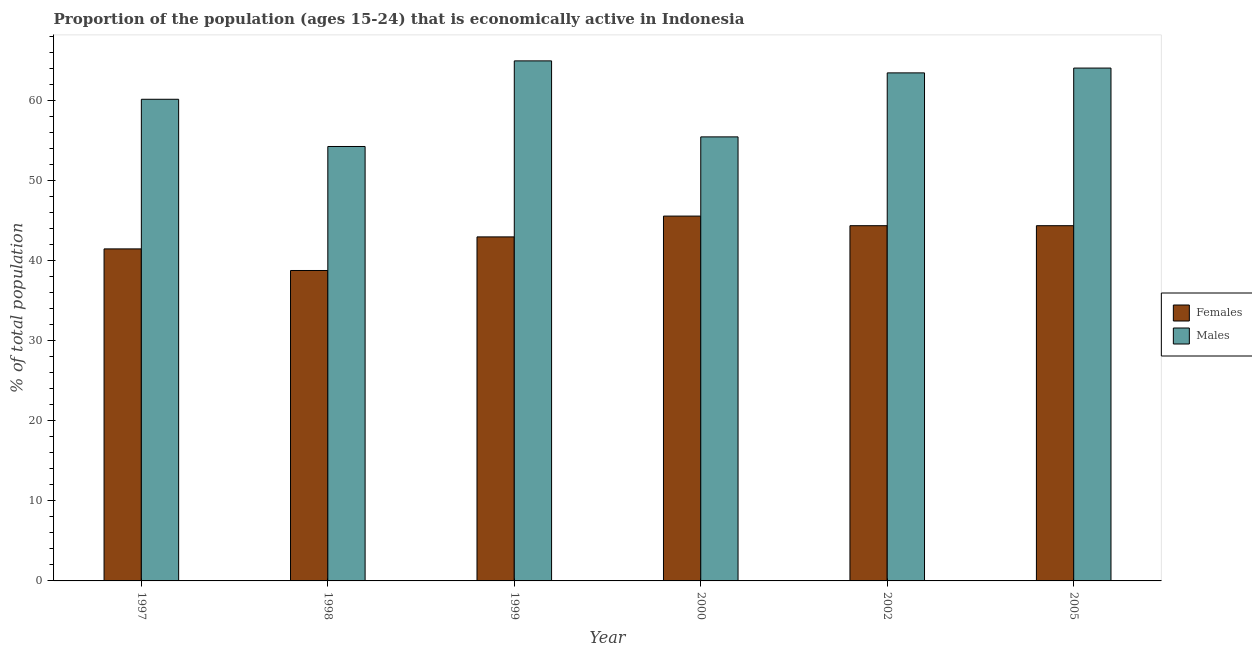How many different coloured bars are there?
Keep it short and to the point. 2. How many groups of bars are there?
Provide a short and direct response. 6. Are the number of bars per tick equal to the number of legend labels?
Offer a terse response. Yes. Are the number of bars on each tick of the X-axis equal?
Provide a succinct answer. Yes. How many bars are there on the 3rd tick from the left?
Your response must be concise. 2. What is the label of the 4th group of bars from the left?
Give a very brief answer. 2000. What is the percentage of economically active female population in 1997?
Provide a short and direct response. 41.5. Across all years, what is the maximum percentage of economically active male population?
Your answer should be compact. 65. Across all years, what is the minimum percentage of economically active male population?
Provide a short and direct response. 54.3. In which year was the percentage of economically active female population maximum?
Keep it short and to the point. 2000. What is the total percentage of economically active female population in the graph?
Provide a short and direct response. 257.7. What is the difference between the percentage of economically active male population in 1999 and that in 2005?
Give a very brief answer. 0.9. What is the difference between the percentage of economically active female population in 2005 and the percentage of economically active male population in 1999?
Provide a succinct answer. 1.4. What is the average percentage of economically active male population per year?
Provide a short and direct response. 60.43. In the year 2002, what is the difference between the percentage of economically active male population and percentage of economically active female population?
Provide a short and direct response. 0. In how many years, is the percentage of economically active male population greater than 30 %?
Provide a short and direct response. 6. What is the ratio of the percentage of economically active male population in 1997 to that in 1998?
Your response must be concise. 1.11. Is the percentage of economically active male population in 1998 less than that in 2005?
Give a very brief answer. Yes. Is the difference between the percentage of economically active female population in 2000 and 2002 greater than the difference between the percentage of economically active male population in 2000 and 2002?
Keep it short and to the point. No. What is the difference between the highest and the second highest percentage of economically active female population?
Keep it short and to the point. 1.2. What is the difference between the highest and the lowest percentage of economically active female population?
Offer a very short reply. 6.8. In how many years, is the percentage of economically active female population greater than the average percentage of economically active female population taken over all years?
Give a very brief answer. 4. Is the sum of the percentage of economically active female population in 1997 and 1998 greater than the maximum percentage of economically active male population across all years?
Ensure brevity in your answer.  Yes. What does the 1st bar from the left in 1998 represents?
Keep it short and to the point. Females. What does the 2nd bar from the right in 1998 represents?
Your answer should be very brief. Females. How many bars are there?
Make the answer very short. 12. Are all the bars in the graph horizontal?
Offer a terse response. No. How many years are there in the graph?
Your answer should be compact. 6. What is the difference between two consecutive major ticks on the Y-axis?
Make the answer very short. 10. Are the values on the major ticks of Y-axis written in scientific E-notation?
Offer a terse response. No. Does the graph contain any zero values?
Offer a very short reply. No. Does the graph contain grids?
Keep it short and to the point. No. How many legend labels are there?
Ensure brevity in your answer.  2. What is the title of the graph?
Ensure brevity in your answer.  Proportion of the population (ages 15-24) that is economically active in Indonesia. What is the label or title of the X-axis?
Give a very brief answer. Year. What is the label or title of the Y-axis?
Provide a succinct answer. % of total population. What is the % of total population in Females in 1997?
Your answer should be compact. 41.5. What is the % of total population in Males in 1997?
Provide a succinct answer. 60.2. What is the % of total population of Females in 1998?
Your answer should be very brief. 38.8. What is the % of total population in Males in 1998?
Keep it short and to the point. 54.3. What is the % of total population in Males in 1999?
Give a very brief answer. 65. What is the % of total population of Females in 2000?
Provide a succinct answer. 45.6. What is the % of total population in Males in 2000?
Offer a terse response. 55.5. What is the % of total population in Females in 2002?
Give a very brief answer. 44.4. What is the % of total population in Males in 2002?
Offer a terse response. 63.5. What is the % of total population in Females in 2005?
Provide a short and direct response. 44.4. What is the % of total population in Males in 2005?
Ensure brevity in your answer.  64.1. Across all years, what is the maximum % of total population in Females?
Your response must be concise. 45.6. Across all years, what is the maximum % of total population of Males?
Your answer should be very brief. 65. Across all years, what is the minimum % of total population in Females?
Give a very brief answer. 38.8. Across all years, what is the minimum % of total population in Males?
Offer a terse response. 54.3. What is the total % of total population in Females in the graph?
Your answer should be very brief. 257.7. What is the total % of total population in Males in the graph?
Provide a succinct answer. 362.6. What is the difference between the % of total population in Males in 1997 and that in 1999?
Offer a terse response. -4.8. What is the difference between the % of total population in Males in 1997 and that in 2005?
Keep it short and to the point. -3.9. What is the difference between the % of total population in Males in 1998 and that in 1999?
Ensure brevity in your answer.  -10.7. What is the difference between the % of total population of Females in 1998 and that in 2000?
Your response must be concise. -6.8. What is the difference between the % of total population of Males in 1998 and that in 2000?
Your answer should be very brief. -1.2. What is the difference between the % of total population of Females in 1998 and that in 2002?
Make the answer very short. -5.6. What is the difference between the % of total population in Males in 1998 and that in 2005?
Give a very brief answer. -9.8. What is the difference between the % of total population in Females in 1999 and that in 2000?
Offer a very short reply. -2.6. What is the difference between the % of total population of Males in 1999 and that in 2000?
Offer a very short reply. 9.5. What is the difference between the % of total population in Females in 1999 and that in 2002?
Provide a short and direct response. -1.4. What is the difference between the % of total population in Males in 1999 and that in 2002?
Your response must be concise. 1.5. What is the difference between the % of total population of Females in 1999 and that in 2005?
Ensure brevity in your answer.  -1.4. What is the difference between the % of total population of Males in 2000 and that in 2002?
Ensure brevity in your answer.  -8. What is the difference between the % of total population in Females in 2000 and that in 2005?
Keep it short and to the point. 1.2. What is the difference between the % of total population of Males in 2002 and that in 2005?
Your response must be concise. -0.6. What is the difference between the % of total population of Females in 1997 and the % of total population of Males in 1998?
Your answer should be very brief. -12.8. What is the difference between the % of total population of Females in 1997 and the % of total population of Males in 1999?
Provide a succinct answer. -23.5. What is the difference between the % of total population in Females in 1997 and the % of total population in Males in 2000?
Provide a short and direct response. -14. What is the difference between the % of total population in Females in 1997 and the % of total population in Males in 2005?
Your answer should be compact. -22.6. What is the difference between the % of total population in Females in 1998 and the % of total population in Males in 1999?
Your answer should be compact. -26.2. What is the difference between the % of total population of Females in 1998 and the % of total population of Males in 2000?
Offer a very short reply. -16.7. What is the difference between the % of total population in Females in 1998 and the % of total population in Males in 2002?
Provide a succinct answer. -24.7. What is the difference between the % of total population of Females in 1998 and the % of total population of Males in 2005?
Your response must be concise. -25.3. What is the difference between the % of total population of Females in 1999 and the % of total population of Males in 2002?
Offer a very short reply. -20.5. What is the difference between the % of total population in Females in 1999 and the % of total population in Males in 2005?
Your response must be concise. -21.1. What is the difference between the % of total population of Females in 2000 and the % of total population of Males in 2002?
Keep it short and to the point. -17.9. What is the difference between the % of total population of Females in 2000 and the % of total population of Males in 2005?
Give a very brief answer. -18.5. What is the difference between the % of total population of Females in 2002 and the % of total population of Males in 2005?
Your answer should be very brief. -19.7. What is the average % of total population in Females per year?
Keep it short and to the point. 42.95. What is the average % of total population of Males per year?
Make the answer very short. 60.43. In the year 1997, what is the difference between the % of total population of Females and % of total population of Males?
Your answer should be compact. -18.7. In the year 1998, what is the difference between the % of total population of Females and % of total population of Males?
Provide a succinct answer. -15.5. In the year 2002, what is the difference between the % of total population in Females and % of total population in Males?
Keep it short and to the point. -19.1. In the year 2005, what is the difference between the % of total population of Females and % of total population of Males?
Your answer should be compact. -19.7. What is the ratio of the % of total population of Females in 1997 to that in 1998?
Make the answer very short. 1.07. What is the ratio of the % of total population in Males in 1997 to that in 1998?
Your answer should be compact. 1.11. What is the ratio of the % of total population of Females in 1997 to that in 1999?
Provide a succinct answer. 0.97. What is the ratio of the % of total population in Males in 1997 to that in 1999?
Keep it short and to the point. 0.93. What is the ratio of the % of total population in Females in 1997 to that in 2000?
Your answer should be very brief. 0.91. What is the ratio of the % of total population of Males in 1997 to that in 2000?
Provide a short and direct response. 1.08. What is the ratio of the % of total population in Females in 1997 to that in 2002?
Make the answer very short. 0.93. What is the ratio of the % of total population of Males in 1997 to that in 2002?
Offer a terse response. 0.95. What is the ratio of the % of total population of Females in 1997 to that in 2005?
Your response must be concise. 0.93. What is the ratio of the % of total population in Males in 1997 to that in 2005?
Offer a very short reply. 0.94. What is the ratio of the % of total population of Females in 1998 to that in 1999?
Ensure brevity in your answer.  0.9. What is the ratio of the % of total population of Males in 1998 to that in 1999?
Give a very brief answer. 0.84. What is the ratio of the % of total population of Females in 1998 to that in 2000?
Your answer should be very brief. 0.85. What is the ratio of the % of total population of Males in 1998 to that in 2000?
Your answer should be compact. 0.98. What is the ratio of the % of total population in Females in 1998 to that in 2002?
Your answer should be very brief. 0.87. What is the ratio of the % of total population in Males in 1998 to that in 2002?
Make the answer very short. 0.86. What is the ratio of the % of total population of Females in 1998 to that in 2005?
Keep it short and to the point. 0.87. What is the ratio of the % of total population in Males in 1998 to that in 2005?
Offer a very short reply. 0.85. What is the ratio of the % of total population of Females in 1999 to that in 2000?
Your answer should be compact. 0.94. What is the ratio of the % of total population in Males in 1999 to that in 2000?
Make the answer very short. 1.17. What is the ratio of the % of total population of Females in 1999 to that in 2002?
Give a very brief answer. 0.97. What is the ratio of the % of total population in Males in 1999 to that in 2002?
Give a very brief answer. 1.02. What is the ratio of the % of total population of Females in 1999 to that in 2005?
Keep it short and to the point. 0.97. What is the ratio of the % of total population of Females in 2000 to that in 2002?
Offer a very short reply. 1.03. What is the ratio of the % of total population in Males in 2000 to that in 2002?
Provide a succinct answer. 0.87. What is the ratio of the % of total population in Males in 2000 to that in 2005?
Provide a succinct answer. 0.87. What is the ratio of the % of total population in Males in 2002 to that in 2005?
Offer a very short reply. 0.99. What is the difference between the highest and the lowest % of total population of Females?
Your answer should be very brief. 6.8. What is the difference between the highest and the lowest % of total population of Males?
Your answer should be very brief. 10.7. 